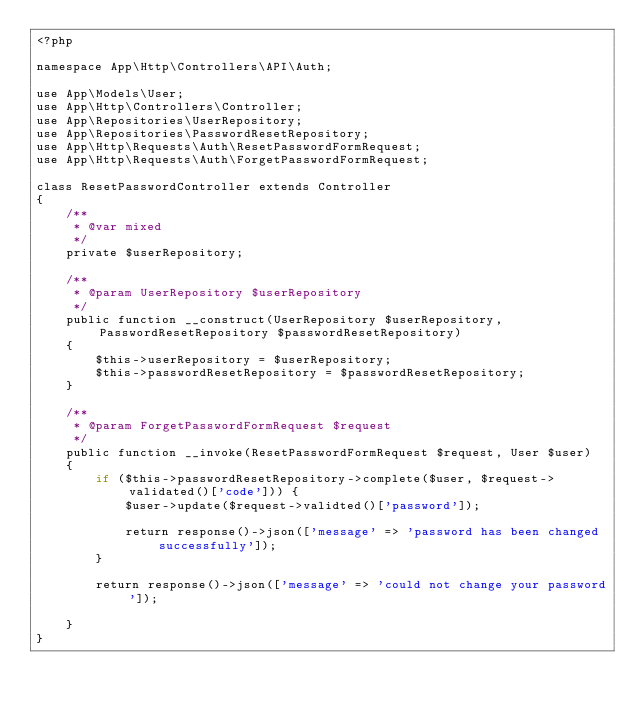<code> <loc_0><loc_0><loc_500><loc_500><_PHP_><?php

namespace App\Http\Controllers\API\Auth;

use App\Models\User;
use App\Http\Controllers\Controller;
use App\Repositories\UserRepository;
use App\Repositories\PasswordResetRepository;
use App\Http\Requests\Auth\ResetPasswordFormRequest;
use App\Http\Requests\Auth\ForgetPasswordFormRequest;

class ResetPasswordController extends Controller
{
    /**
     * @var mixed
     */
    private $userRepository;

    /**
     * @param UserRepository $userRepository
     */
    public function __construct(UserRepository $userRepository, PasswordResetRepository $passwordResetRepository)
    {
        $this->userRepository = $userRepository;
        $this->passwordResetRepository = $passwordResetRepository;
    }

    /**
     * @param ForgetPasswordFormRequest $request
     */
    public function __invoke(ResetPasswordFormRequest $request, User $user)
    {
        if ($this->passwordResetRepository->complete($user, $request->validated()['code'])) {
            $user->update($request->validted()['password']);

            return response()->json(['message' => 'password has been changed successfully']);
        }

        return response()->json(['message' => 'could not change your password']);

    }
}
</code> 